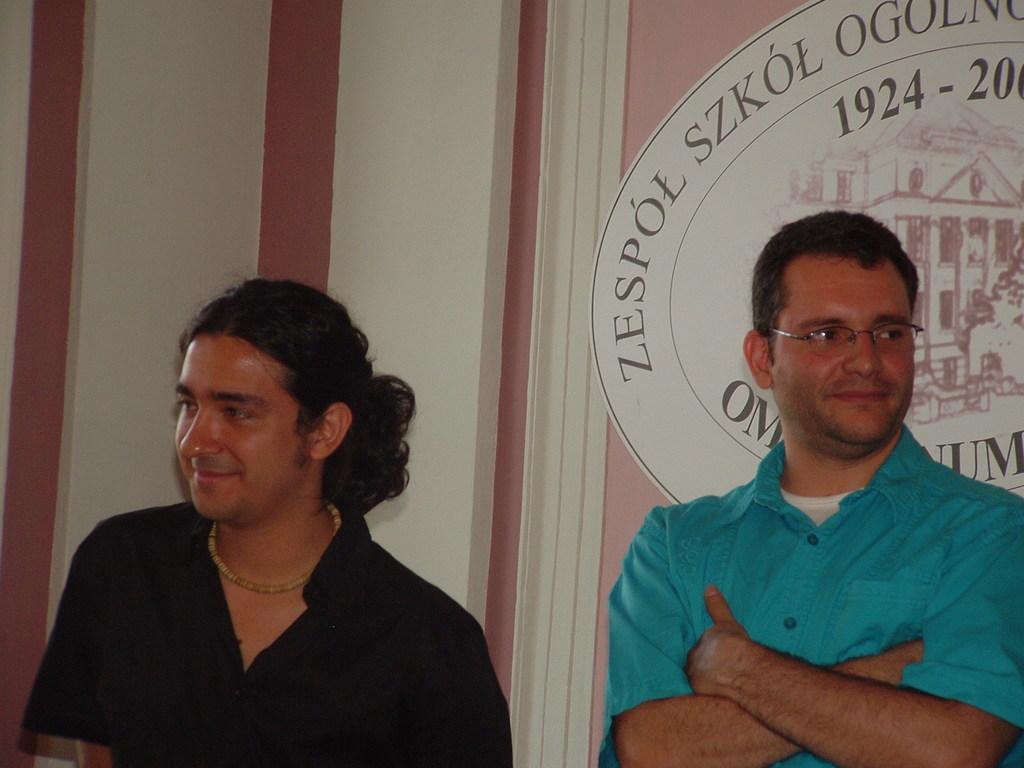In one or two sentences, can you explain what this image depicts? In this picture we can see two men standing and smiling. There is an image of a building on a white board. We can see some numbers on the board. 